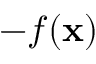<formula> <loc_0><loc_0><loc_500><loc_500>- f ( x )</formula> 